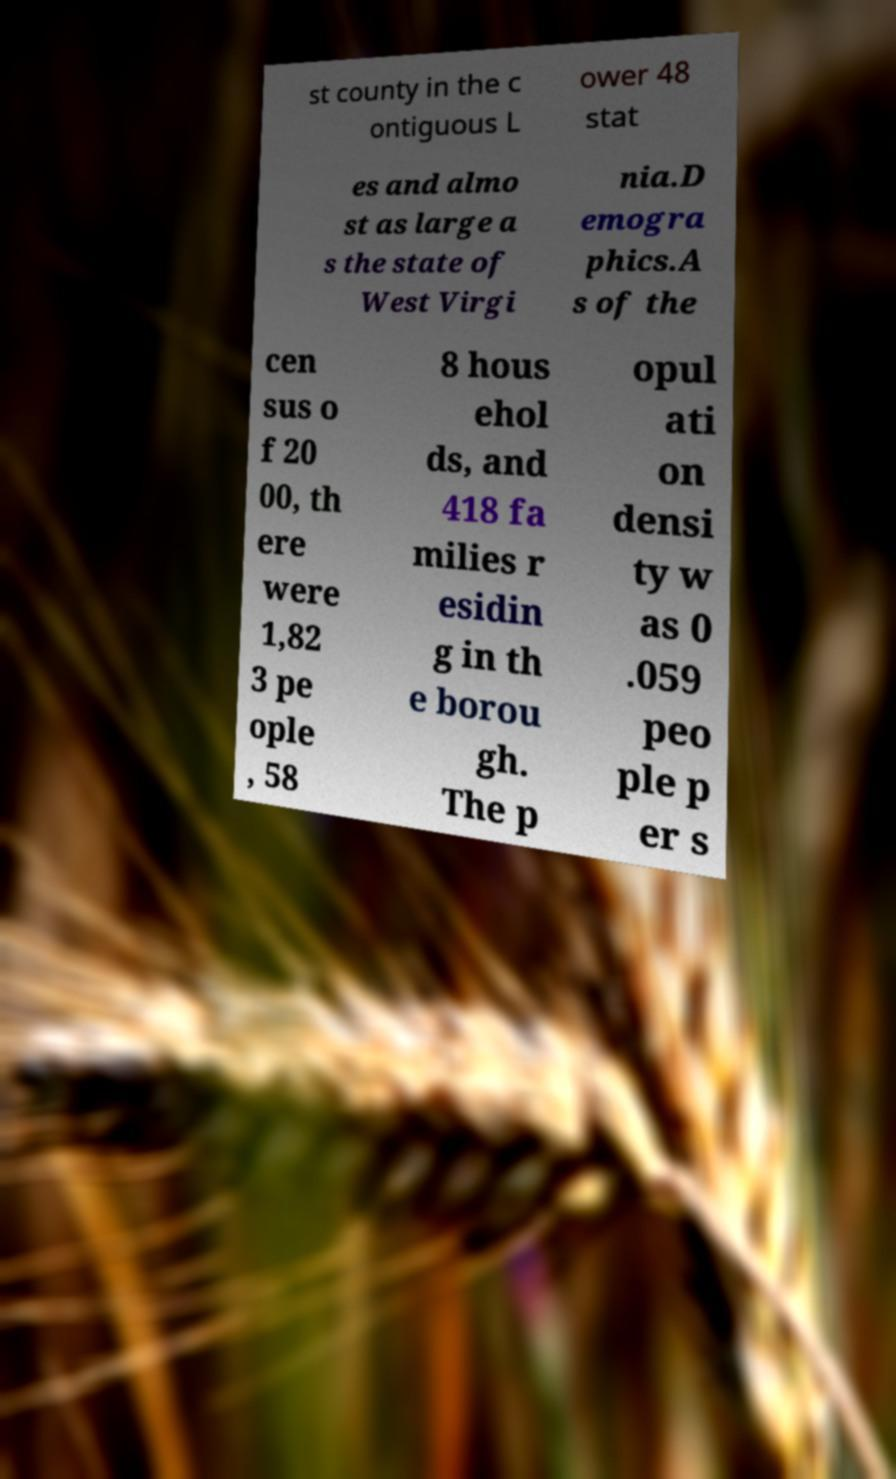I need the written content from this picture converted into text. Can you do that? st county in the c ontiguous L ower 48 stat es and almo st as large a s the state of West Virgi nia.D emogra phics.A s of the cen sus o f 20 00, th ere were 1,82 3 pe ople , 58 8 hous ehol ds, and 418 fa milies r esidin g in th e borou gh. The p opul ati on densi ty w as 0 .059 peo ple p er s 